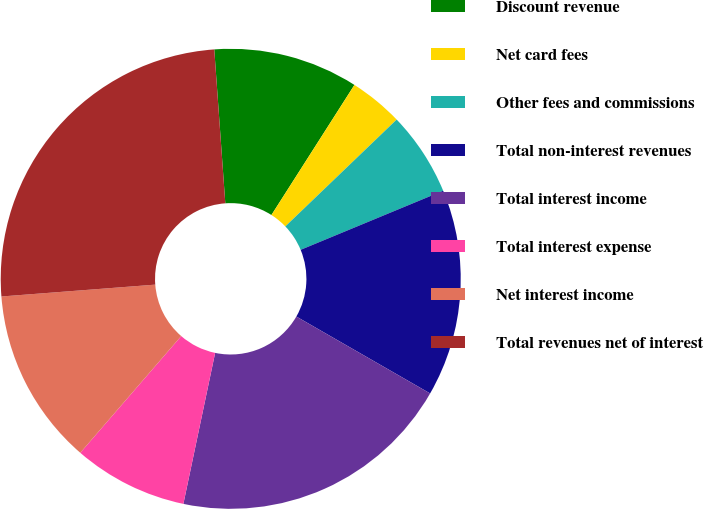Convert chart. <chart><loc_0><loc_0><loc_500><loc_500><pie_chart><fcel>Discount revenue<fcel>Net card fees<fcel>Other fees and commissions<fcel>Total non-interest revenues<fcel>Total interest income<fcel>Total interest expense<fcel>Net interest income<fcel>Total revenues net of interest<nl><fcel>10.18%<fcel>3.79%<fcel>5.92%<fcel>14.56%<fcel>20.0%<fcel>8.05%<fcel>12.43%<fcel>25.09%<nl></chart> 